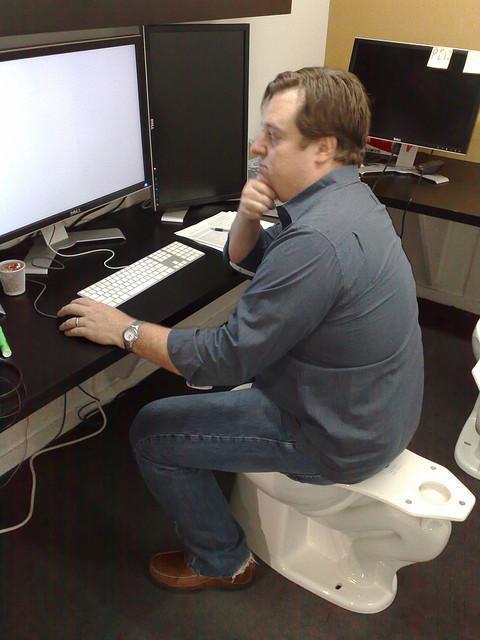What part of this mans furniture is most surprising?
Select the accurate answer and provide explanation: 'Answer: answer
Rationale: rationale.'
Options: Desk, toilet, speaker, flooring holder. Answer: toilet.
Rationale: The man seems to be  be sitting on the toilet. 